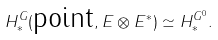Convert formula to latex. <formula><loc_0><loc_0><loc_500><loc_500>H ^ { G } _ { * } ( \text {point} , E \otimes E ^ { * } ) \simeq H ^ { G ^ { 0 } } _ { * } .</formula> 